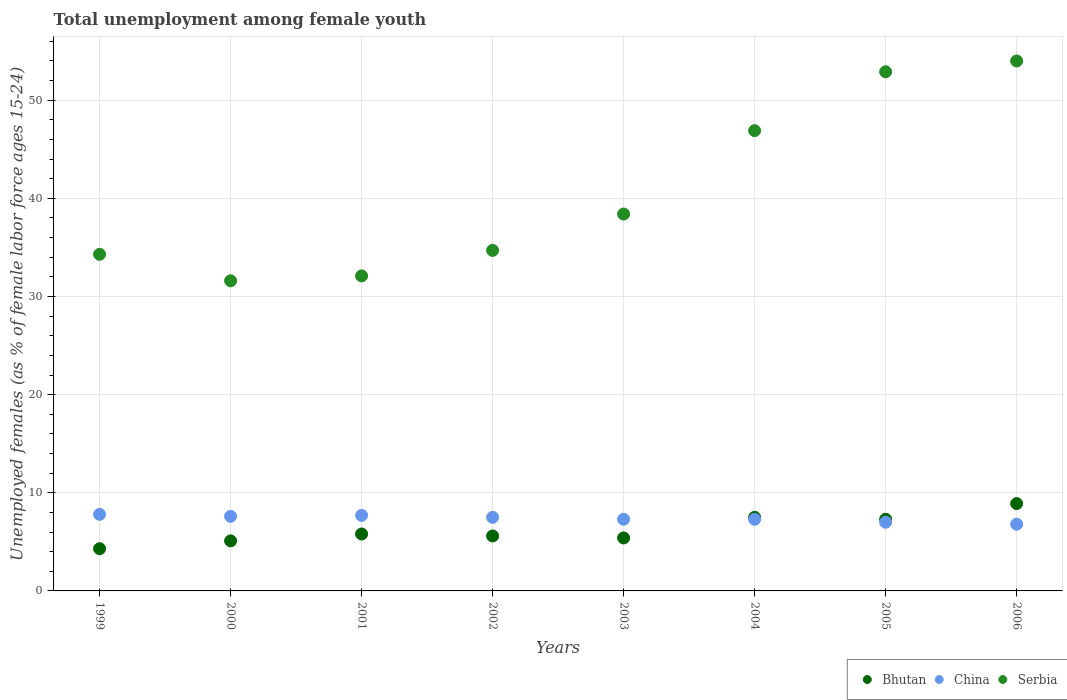What is the percentage of unemployed females in in China in 2001?
Give a very brief answer. 7.7. Across all years, what is the minimum percentage of unemployed females in in Bhutan?
Your response must be concise. 4.3. In which year was the percentage of unemployed females in in China maximum?
Provide a succinct answer. 1999. In which year was the percentage of unemployed females in in China minimum?
Offer a very short reply. 2006. What is the total percentage of unemployed females in in China in the graph?
Ensure brevity in your answer.  59. What is the difference between the percentage of unemployed females in in Serbia in 1999 and that in 2005?
Your answer should be very brief. -18.6. What is the difference between the percentage of unemployed females in in Serbia in 2000 and the percentage of unemployed females in in China in 2001?
Provide a short and direct response. 23.9. What is the average percentage of unemployed females in in Bhutan per year?
Your answer should be very brief. 6.24. In the year 2000, what is the difference between the percentage of unemployed females in in China and percentage of unemployed females in in Bhutan?
Provide a succinct answer. 2.5. In how many years, is the percentage of unemployed females in in Serbia greater than 24 %?
Offer a terse response. 8. What is the ratio of the percentage of unemployed females in in Bhutan in 2005 to that in 2006?
Your response must be concise. 0.82. Is the percentage of unemployed females in in China in 2001 less than that in 2004?
Offer a terse response. No. What is the difference between the highest and the second highest percentage of unemployed females in in Serbia?
Give a very brief answer. 1.1. In how many years, is the percentage of unemployed females in in Serbia greater than the average percentage of unemployed females in in Serbia taken over all years?
Keep it short and to the point. 3. Is the percentage of unemployed females in in Serbia strictly greater than the percentage of unemployed females in in Bhutan over the years?
Provide a short and direct response. Yes. How many dotlines are there?
Provide a short and direct response. 3. Are the values on the major ticks of Y-axis written in scientific E-notation?
Provide a succinct answer. No. Does the graph contain any zero values?
Ensure brevity in your answer.  No. Does the graph contain grids?
Provide a succinct answer. Yes. How are the legend labels stacked?
Offer a terse response. Horizontal. What is the title of the graph?
Keep it short and to the point. Total unemployment among female youth. Does "Turkey" appear as one of the legend labels in the graph?
Provide a succinct answer. No. What is the label or title of the Y-axis?
Your answer should be very brief. Unemployed females (as % of female labor force ages 15-24). What is the Unemployed females (as % of female labor force ages 15-24) of Bhutan in 1999?
Your response must be concise. 4.3. What is the Unemployed females (as % of female labor force ages 15-24) of China in 1999?
Your answer should be compact. 7.8. What is the Unemployed females (as % of female labor force ages 15-24) in Serbia in 1999?
Keep it short and to the point. 34.3. What is the Unemployed females (as % of female labor force ages 15-24) in Bhutan in 2000?
Your answer should be very brief. 5.1. What is the Unemployed females (as % of female labor force ages 15-24) of China in 2000?
Offer a very short reply. 7.6. What is the Unemployed females (as % of female labor force ages 15-24) of Serbia in 2000?
Give a very brief answer. 31.6. What is the Unemployed females (as % of female labor force ages 15-24) in Bhutan in 2001?
Ensure brevity in your answer.  5.8. What is the Unemployed females (as % of female labor force ages 15-24) in China in 2001?
Provide a succinct answer. 7.7. What is the Unemployed females (as % of female labor force ages 15-24) of Serbia in 2001?
Provide a short and direct response. 32.1. What is the Unemployed females (as % of female labor force ages 15-24) in Bhutan in 2002?
Keep it short and to the point. 5.6. What is the Unemployed females (as % of female labor force ages 15-24) of China in 2002?
Give a very brief answer. 7.5. What is the Unemployed females (as % of female labor force ages 15-24) in Serbia in 2002?
Provide a short and direct response. 34.7. What is the Unemployed females (as % of female labor force ages 15-24) of Bhutan in 2003?
Your answer should be very brief. 5.4. What is the Unemployed females (as % of female labor force ages 15-24) in China in 2003?
Keep it short and to the point. 7.3. What is the Unemployed females (as % of female labor force ages 15-24) in Serbia in 2003?
Make the answer very short. 38.4. What is the Unemployed females (as % of female labor force ages 15-24) of Bhutan in 2004?
Make the answer very short. 7.5. What is the Unemployed females (as % of female labor force ages 15-24) in China in 2004?
Your answer should be very brief. 7.3. What is the Unemployed females (as % of female labor force ages 15-24) of Serbia in 2004?
Your answer should be very brief. 46.9. What is the Unemployed females (as % of female labor force ages 15-24) in Bhutan in 2005?
Offer a terse response. 7.3. What is the Unemployed females (as % of female labor force ages 15-24) of China in 2005?
Give a very brief answer. 7. What is the Unemployed females (as % of female labor force ages 15-24) in Serbia in 2005?
Ensure brevity in your answer.  52.9. What is the Unemployed females (as % of female labor force ages 15-24) in Bhutan in 2006?
Ensure brevity in your answer.  8.9. What is the Unemployed females (as % of female labor force ages 15-24) of China in 2006?
Provide a succinct answer. 6.8. Across all years, what is the maximum Unemployed females (as % of female labor force ages 15-24) of Bhutan?
Provide a short and direct response. 8.9. Across all years, what is the maximum Unemployed females (as % of female labor force ages 15-24) of China?
Offer a terse response. 7.8. Across all years, what is the maximum Unemployed females (as % of female labor force ages 15-24) in Serbia?
Make the answer very short. 54. Across all years, what is the minimum Unemployed females (as % of female labor force ages 15-24) of Bhutan?
Provide a short and direct response. 4.3. Across all years, what is the minimum Unemployed females (as % of female labor force ages 15-24) of China?
Your answer should be compact. 6.8. Across all years, what is the minimum Unemployed females (as % of female labor force ages 15-24) in Serbia?
Your answer should be very brief. 31.6. What is the total Unemployed females (as % of female labor force ages 15-24) of Bhutan in the graph?
Provide a succinct answer. 49.9. What is the total Unemployed females (as % of female labor force ages 15-24) of Serbia in the graph?
Your answer should be very brief. 324.9. What is the difference between the Unemployed females (as % of female labor force ages 15-24) in Bhutan in 1999 and that in 2000?
Make the answer very short. -0.8. What is the difference between the Unemployed females (as % of female labor force ages 15-24) of China in 1999 and that in 2000?
Provide a succinct answer. 0.2. What is the difference between the Unemployed females (as % of female labor force ages 15-24) in Bhutan in 1999 and that in 2001?
Offer a very short reply. -1.5. What is the difference between the Unemployed females (as % of female labor force ages 15-24) in China in 1999 and that in 2001?
Provide a succinct answer. 0.1. What is the difference between the Unemployed females (as % of female labor force ages 15-24) of China in 1999 and that in 2002?
Provide a short and direct response. 0.3. What is the difference between the Unemployed females (as % of female labor force ages 15-24) of Bhutan in 1999 and that in 2003?
Give a very brief answer. -1.1. What is the difference between the Unemployed females (as % of female labor force ages 15-24) of Serbia in 1999 and that in 2004?
Your answer should be very brief. -12.6. What is the difference between the Unemployed females (as % of female labor force ages 15-24) in Serbia in 1999 and that in 2005?
Your response must be concise. -18.6. What is the difference between the Unemployed females (as % of female labor force ages 15-24) in Bhutan in 1999 and that in 2006?
Offer a very short reply. -4.6. What is the difference between the Unemployed females (as % of female labor force ages 15-24) of China in 1999 and that in 2006?
Your answer should be compact. 1. What is the difference between the Unemployed females (as % of female labor force ages 15-24) in Serbia in 1999 and that in 2006?
Provide a succinct answer. -19.7. What is the difference between the Unemployed females (as % of female labor force ages 15-24) in Serbia in 2000 and that in 2001?
Make the answer very short. -0.5. What is the difference between the Unemployed females (as % of female labor force ages 15-24) of Bhutan in 2000 and that in 2002?
Give a very brief answer. -0.5. What is the difference between the Unemployed females (as % of female labor force ages 15-24) of Serbia in 2000 and that in 2002?
Ensure brevity in your answer.  -3.1. What is the difference between the Unemployed females (as % of female labor force ages 15-24) in Bhutan in 2000 and that in 2003?
Offer a terse response. -0.3. What is the difference between the Unemployed females (as % of female labor force ages 15-24) of Serbia in 2000 and that in 2004?
Provide a succinct answer. -15.3. What is the difference between the Unemployed females (as % of female labor force ages 15-24) of China in 2000 and that in 2005?
Keep it short and to the point. 0.6. What is the difference between the Unemployed females (as % of female labor force ages 15-24) of Serbia in 2000 and that in 2005?
Ensure brevity in your answer.  -21.3. What is the difference between the Unemployed females (as % of female labor force ages 15-24) in Serbia in 2000 and that in 2006?
Give a very brief answer. -22.4. What is the difference between the Unemployed females (as % of female labor force ages 15-24) of China in 2001 and that in 2002?
Your answer should be compact. 0.2. What is the difference between the Unemployed females (as % of female labor force ages 15-24) of Bhutan in 2001 and that in 2003?
Keep it short and to the point. 0.4. What is the difference between the Unemployed females (as % of female labor force ages 15-24) in China in 2001 and that in 2003?
Your answer should be compact. 0.4. What is the difference between the Unemployed females (as % of female labor force ages 15-24) of China in 2001 and that in 2004?
Give a very brief answer. 0.4. What is the difference between the Unemployed females (as % of female labor force ages 15-24) of Serbia in 2001 and that in 2004?
Provide a succinct answer. -14.8. What is the difference between the Unemployed females (as % of female labor force ages 15-24) in Serbia in 2001 and that in 2005?
Your answer should be compact. -20.8. What is the difference between the Unemployed females (as % of female labor force ages 15-24) of Bhutan in 2001 and that in 2006?
Provide a succinct answer. -3.1. What is the difference between the Unemployed females (as % of female labor force ages 15-24) in Serbia in 2001 and that in 2006?
Your answer should be very brief. -21.9. What is the difference between the Unemployed females (as % of female labor force ages 15-24) in Bhutan in 2002 and that in 2003?
Make the answer very short. 0.2. What is the difference between the Unemployed females (as % of female labor force ages 15-24) in China in 2002 and that in 2003?
Your response must be concise. 0.2. What is the difference between the Unemployed females (as % of female labor force ages 15-24) in Serbia in 2002 and that in 2003?
Your answer should be compact. -3.7. What is the difference between the Unemployed females (as % of female labor force ages 15-24) in Bhutan in 2002 and that in 2004?
Offer a very short reply. -1.9. What is the difference between the Unemployed females (as % of female labor force ages 15-24) in China in 2002 and that in 2004?
Provide a succinct answer. 0.2. What is the difference between the Unemployed females (as % of female labor force ages 15-24) of Serbia in 2002 and that in 2005?
Offer a terse response. -18.2. What is the difference between the Unemployed females (as % of female labor force ages 15-24) in Bhutan in 2002 and that in 2006?
Give a very brief answer. -3.3. What is the difference between the Unemployed females (as % of female labor force ages 15-24) in Serbia in 2002 and that in 2006?
Ensure brevity in your answer.  -19.3. What is the difference between the Unemployed females (as % of female labor force ages 15-24) in China in 2003 and that in 2004?
Give a very brief answer. 0. What is the difference between the Unemployed females (as % of female labor force ages 15-24) in Bhutan in 2003 and that in 2006?
Offer a terse response. -3.5. What is the difference between the Unemployed females (as % of female labor force ages 15-24) of Serbia in 2003 and that in 2006?
Make the answer very short. -15.6. What is the difference between the Unemployed females (as % of female labor force ages 15-24) of Bhutan in 2004 and that in 2005?
Your answer should be compact. 0.2. What is the difference between the Unemployed females (as % of female labor force ages 15-24) of Bhutan in 2005 and that in 2006?
Make the answer very short. -1.6. What is the difference between the Unemployed females (as % of female labor force ages 15-24) of China in 2005 and that in 2006?
Offer a terse response. 0.2. What is the difference between the Unemployed females (as % of female labor force ages 15-24) of Bhutan in 1999 and the Unemployed females (as % of female labor force ages 15-24) of Serbia in 2000?
Provide a succinct answer. -27.3. What is the difference between the Unemployed females (as % of female labor force ages 15-24) of China in 1999 and the Unemployed females (as % of female labor force ages 15-24) of Serbia in 2000?
Provide a succinct answer. -23.8. What is the difference between the Unemployed females (as % of female labor force ages 15-24) in Bhutan in 1999 and the Unemployed females (as % of female labor force ages 15-24) in China in 2001?
Offer a terse response. -3.4. What is the difference between the Unemployed females (as % of female labor force ages 15-24) of Bhutan in 1999 and the Unemployed females (as % of female labor force ages 15-24) of Serbia in 2001?
Make the answer very short. -27.8. What is the difference between the Unemployed females (as % of female labor force ages 15-24) of China in 1999 and the Unemployed females (as % of female labor force ages 15-24) of Serbia in 2001?
Offer a terse response. -24.3. What is the difference between the Unemployed females (as % of female labor force ages 15-24) of Bhutan in 1999 and the Unemployed females (as % of female labor force ages 15-24) of China in 2002?
Ensure brevity in your answer.  -3.2. What is the difference between the Unemployed females (as % of female labor force ages 15-24) of Bhutan in 1999 and the Unemployed females (as % of female labor force ages 15-24) of Serbia in 2002?
Provide a succinct answer. -30.4. What is the difference between the Unemployed females (as % of female labor force ages 15-24) in China in 1999 and the Unemployed females (as % of female labor force ages 15-24) in Serbia in 2002?
Provide a succinct answer. -26.9. What is the difference between the Unemployed females (as % of female labor force ages 15-24) in Bhutan in 1999 and the Unemployed females (as % of female labor force ages 15-24) in Serbia in 2003?
Give a very brief answer. -34.1. What is the difference between the Unemployed females (as % of female labor force ages 15-24) in China in 1999 and the Unemployed females (as % of female labor force ages 15-24) in Serbia in 2003?
Offer a terse response. -30.6. What is the difference between the Unemployed females (as % of female labor force ages 15-24) of Bhutan in 1999 and the Unemployed females (as % of female labor force ages 15-24) of Serbia in 2004?
Provide a short and direct response. -42.6. What is the difference between the Unemployed females (as % of female labor force ages 15-24) of China in 1999 and the Unemployed females (as % of female labor force ages 15-24) of Serbia in 2004?
Your answer should be very brief. -39.1. What is the difference between the Unemployed females (as % of female labor force ages 15-24) in Bhutan in 1999 and the Unemployed females (as % of female labor force ages 15-24) in Serbia in 2005?
Offer a very short reply. -48.6. What is the difference between the Unemployed females (as % of female labor force ages 15-24) of China in 1999 and the Unemployed females (as % of female labor force ages 15-24) of Serbia in 2005?
Make the answer very short. -45.1. What is the difference between the Unemployed females (as % of female labor force ages 15-24) in Bhutan in 1999 and the Unemployed females (as % of female labor force ages 15-24) in Serbia in 2006?
Your answer should be compact. -49.7. What is the difference between the Unemployed females (as % of female labor force ages 15-24) of China in 1999 and the Unemployed females (as % of female labor force ages 15-24) of Serbia in 2006?
Offer a terse response. -46.2. What is the difference between the Unemployed females (as % of female labor force ages 15-24) of Bhutan in 2000 and the Unemployed females (as % of female labor force ages 15-24) of China in 2001?
Provide a short and direct response. -2.6. What is the difference between the Unemployed females (as % of female labor force ages 15-24) in Bhutan in 2000 and the Unemployed females (as % of female labor force ages 15-24) in Serbia in 2001?
Offer a terse response. -27. What is the difference between the Unemployed females (as % of female labor force ages 15-24) of China in 2000 and the Unemployed females (as % of female labor force ages 15-24) of Serbia in 2001?
Provide a succinct answer. -24.5. What is the difference between the Unemployed females (as % of female labor force ages 15-24) of Bhutan in 2000 and the Unemployed females (as % of female labor force ages 15-24) of Serbia in 2002?
Your response must be concise. -29.6. What is the difference between the Unemployed females (as % of female labor force ages 15-24) of China in 2000 and the Unemployed females (as % of female labor force ages 15-24) of Serbia in 2002?
Make the answer very short. -27.1. What is the difference between the Unemployed females (as % of female labor force ages 15-24) of Bhutan in 2000 and the Unemployed females (as % of female labor force ages 15-24) of Serbia in 2003?
Your answer should be compact. -33.3. What is the difference between the Unemployed females (as % of female labor force ages 15-24) of China in 2000 and the Unemployed females (as % of female labor force ages 15-24) of Serbia in 2003?
Offer a very short reply. -30.8. What is the difference between the Unemployed females (as % of female labor force ages 15-24) of Bhutan in 2000 and the Unemployed females (as % of female labor force ages 15-24) of China in 2004?
Your response must be concise. -2.2. What is the difference between the Unemployed females (as % of female labor force ages 15-24) in Bhutan in 2000 and the Unemployed females (as % of female labor force ages 15-24) in Serbia in 2004?
Make the answer very short. -41.8. What is the difference between the Unemployed females (as % of female labor force ages 15-24) of China in 2000 and the Unemployed females (as % of female labor force ages 15-24) of Serbia in 2004?
Offer a very short reply. -39.3. What is the difference between the Unemployed females (as % of female labor force ages 15-24) of Bhutan in 2000 and the Unemployed females (as % of female labor force ages 15-24) of China in 2005?
Offer a very short reply. -1.9. What is the difference between the Unemployed females (as % of female labor force ages 15-24) of Bhutan in 2000 and the Unemployed females (as % of female labor force ages 15-24) of Serbia in 2005?
Give a very brief answer. -47.8. What is the difference between the Unemployed females (as % of female labor force ages 15-24) of China in 2000 and the Unemployed females (as % of female labor force ages 15-24) of Serbia in 2005?
Give a very brief answer. -45.3. What is the difference between the Unemployed females (as % of female labor force ages 15-24) in Bhutan in 2000 and the Unemployed females (as % of female labor force ages 15-24) in China in 2006?
Make the answer very short. -1.7. What is the difference between the Unemployed females (as % of female labor force ages 15-24) of Bhutan in 2000 and the Unemployed females (as % of female labor force ages 15-24) of Serbia in 2006?
Your response must be concise. -48.9. What is the difference between the Unemployed females (as % of female labor force ages 15-24) of China in 2000 and the Unemployed females (as % of female labor force ages 15-24) of Serbia in 2006?
Provide a succinct answer. -46.4. What is the difference between the Unemployed females (as % of female labor force ages 15-24) in Bhutan in 2001 and the Unemployed females (as % of female labor force ages 15-24) in Serbia in 2002?
Make the answer very short. -28.9. What is the difference between the Unemployed females (as % of female labor force ages 15-24) of China in 2001 and the Unemployed females (as % of female labor force ages 15-24) of Serbia in 2002?
Your answer should be compact. -27. What is the difference between the Unemployed females (as % of female labor force ages 15-24) in Bhutan in 2001 and the Unemployed females (as % of female labor force ages 15-24) in Serbia in 2003?
Offer a terse response. -32.6. What is the difference between the Unemployed females (as % of female labor force ages 15-24) of China in 2001 and the Unemployed females (as % of female labor force ages 15-24) of Serbia in 2003?
Offer a terse response. -30.7. What is the difference between the Unemployed females (as % of female labor force ages 15-24) in Bhutan in 2001 and the Unemployed females (as % of female labor force ages 15-24) in Serbia in 2004?
Give a very brief answer. -41.1. What is the difference between the Unemployed females (as % of female labor force ages 15-24) in China in 2001 and the Unemployed females (as % of female labor force ages 15-24) in Serbia in 2004?
Make the answer very short. -39.2. What is the difference between the Unemployed females (as % of female labor force ages 15-24) of Bhutan in 2001 and the Unemployed females (as % of female labor force ages 15-24) of Serbia in 2005?
Give a very brief answer. -47.1. What is the difference between the Unemployed females (as % of female labor force ages 15-24) in China in 2001 and the Unemployed females (as % of female labor force ages 15-24) in Serbia in 2005?
Ensure brevity in your answer.  -45.2. What is the difference between the Unemployed females (as % of female labor force ages 15-24) in Bhutan in 2001 and the Unemployed females (as % of female labor force ages 15-24) in Serbia in 2006?
Give a very brief answer. -48.2. What is the difference between the Unemployed females (as % of female labor force ages 15-24) of China in 2001 and the Unemployed females (as % of female labor force ages 15-24) of Serbia in 2006?
Ensure brevity in your answer.  -46.3. What is the difference between the Unemployed females (as % of female labor force ages 15-24) of Bhutan in 2002 and the Unemployed females (as % of female labor force ages 15-24) of China in 2003?
Ensure brevity in your answer.  -1.7. What is the difference between the Unemployed females (as % of female labor force ages 15-24) of Bhutan in 2002 and the Unemployed females (as % of female labor force ages 15-24) of Serbia in 2003?
Offer a very short reply. -32.8. What is the difference between the Unemployed females (as % of female labor force ages 15-24) of China in 2002 and the Unemployed females (as % of female labor force ages 15-24) of Serbia in 2003?
Make the answer very short. -30.9. What is the difference between the Unemployed females (as % of female labor force ages 15-24) of Bhutan in 2002 and the Unemployed females (as % of female labor force ages 15-24) of Serbia in 2004?
Provide a succinct answer. -41.3. What is the difference between the Unemployed females (as % of female labor force ages 15-24) of China in 2002 and the Unemployed females (as % of female labor force ages 15-24) of Serbia in 2004?
Offer a terse response. -39.4. What is the difference between the Unemployed females (as % of female labor force ages 15-24) of Bhutan in 2002 and the Unemployed females (as % of female labor force ages 15-24) of Serbia in 2005?
Provide a succinct answer. -47.3. What is the difference between the Unemployed females (as % of female labor force ages 15-24) in China in 2002 and the Unemployed females (as % of female labor force ages 15-24) in Serbia in 2005?
Your response must be concise. -45.4. What is the difference between the Unemployed females (as % of female labor force ages 15-24) in Bhutan in 2002 and the Unemployed females (as % of female labor force ages 15-24) in Serbia in 2006?
Offer a very short reply. -48.4. What is the difference between the Unemployed females (as % of female labor force ages 15-24) of China in 2002 and the Unemployed females (as % of female labor force ages 15-24) of Serbia in 2006?
Give a very brief answer. -46.5. What is the difference between the Unemployed females (as % of female labor force ages 15-24) of Bhutan in 2003 and the Unemployed females (as % of female labor force ages 15-24) of China in 2004?
Provide a succinct answer. -1.9. What is the difference between the Unemployed females (as % of female labor force ages 15-24) in Bhutan in 2003 and the Unemployed females (as % of female labor force ages 15-24) in Serbia in 2004?
Ensure brevity in your answer.  -41.5. What is the difference between the Unemployed females (as % of female labor force ages 15-24) in China in 2003 and the Unemployed females (as % of female labor force ages 15-24) in Serbia in 2004?
Offer a very short reply. -39.6. What is the difference between the Unemployed females (as % of female labor force ages 15-24) of Bhutan in 2003 and the Unemployed females (as % of female labor force ages 15-24) of Serbia in 2005?
Keep it short and to the point. -47.5. What is the difference between the Unemployed females (as % of female labor force ages 15-24) in China in 2003 and the Unemployed females (as % of female labor force ages 15-24) in Serbia in 2005?
Offer a very short reply. -45.6. What is the difference between the Unemployed females (as % of female labor force ages 15-24) in Bhutan in 2003 and the Unemployed females (as % of female labor force ages 15-24) in Serbia in 2006?
Ensure brevity in your answer.  -48.6. What is the difference between the Unemployed females (as % of female labor force ages 15-24) in China in 2003 and the Unemployed females (as % of female labor force ages 15-24) in Serbia in 2006?
Provide a short and direct response. -46.7. What is the difference between the Unemployed females (as % of female labor force ages 15-24) of Bhutan in 2004 and the Unemployed females (as % of female labor force ages 15-24) of Serbia in 2005?
Offer a terse response. -45.4. What is the difference between the Unemployed females (as % of female labor force ages 15-24) of China in 2004 and the Unemployed females (as % of female labor force ages 15-24) of Serbia in 2005?
Your answer should be compact. -45.6. What is the difference between the Unemployed females (as % of female labor force ages 15-24) in Bhutan in 2004 and the Unemployed females (as % of female labor force ages 15-24) in China in 2006?
Offer a very short reply. 0.7. What is the difference between the Unemployed females (as % of female labor force ages 15-24) in Bhutan in 2004 and the Unemployed females (as % of female labor force ages 15-24) in Serbia in 2006?
Give a very brief answer. -46.5. What is the difference between the Unemployed females (as % of female labor force ages 15-24) of China in 2004 and the Unemployed females (as % of female labor force ages 15-24) of Serbia in 2006?
Give a very brief answer. -46.7. What is the difference between the Unemployed females (as % of female labor force ages 15-24) of Bhutan in 2005 and the Unemployed females (as % of female labor force ages 15-24) of Serbia in 2006?
Offer a terse response. -46.7. What is the difference between the Unemployed females (as % of female labor force ages 15-24) of China in 2005 and the Unemployed females (as % of female labor force ages 15-24) of Serbia in 2006?
Your response must be concise. -47. What is the average Unemployed females (as % of female labor force ages 15-24) of Bhutan per year?
Your response must be concise. 6.24. What is the average Unemployed females (as % of female labor force ages 15-24) of China per year?
Ensure brevity in your answer.  7.38. What is the average Unemployed females (as % of female labor force ages 15-24) of Serbia per year?
Give a very brief answer. 40.61. In the year 1999, what is the difference between the Unemployed females (as % of female labor force ages 15-24) of Bhutan and Unemployed females (as % of female labor force ages 15-24) of China?
Give a very brief answer. -3.5. In the year 1999, what is the difference between the Unemployed females (as % of female labor force ages 15-24) in China and Unemployed females (as % of female labor force ages 15-24) in Serbia?
Provide a succinct answer. -26.5. In the year 2000, what is the difference between the Unemployed females (as % of female labor force ages 15-24) of Bhutan and Unemployed females (as % of female labor force ages 15-24) of China?
Offer a very short reply. -2.5. In the year 2000, what is the difference between the Unemployed females (as % of female labor force ages 15-24) in Bhutan and Unemployed females (as % of female labor force ages 15-24) in Serbia?
Your answer should be compact. -26.5. In the year 2000, what is the difference between the Unemployed females (as % of female labor force ages 15-24) of China and Unemployed females (as % of female labor force ages 15-24) of Serbia?
Ensure brevity in your answer.  -24. In the year 2001, what is the difference between the Unemployed females (as % of female labor force ages 15-24) in Bhutan and Unemployed females (as % of female labor force ages 15-24) in Serbia?
Your answer should be compact. -26.3. In the year 2001, what is the difference between the Unemployed females (as % of female labor force ages 15-24) in China and Unemployed females (as % of female labor force ages 15-24) in Serbia?
Your response must be concise. -24.4. In the year 2002, what is the difference between the Unemployed females (as % of female labor force ages 15-24) of Bhutan and Unemployed females (as % of female labor force ages 15-24) of Serbia?
Provide a short and direct response. -29.1. In the year 2002, what is the difference between the Unemployed females (as % of female labor force ages 15-24) of China and Unemployed females (as % of female labor force ages 15-24) of Serbia?
Offer a terse response. -27.2. In the year 2003, what is the difference between the Unemployed females (as % of female labor force ages 15-24) of Bhutan and Unemployed females (as % of female labor force ages 15-24) of Serbia?
Your answer should be very brief. -33. In the year 2003, what is the difference between the Unemployed females (as % of female labor force ages 15-24) of China and Unemployed females (as % of female labor force ages 15-24) of Serbia?
Offer a very short reply. -31.1. In the year 2004, what is the difference between the Unemployed females (as % of female labor force ages 15-24) of Bhutan and Unemployed females (as % of female labor force ages 15-24) of China?
Offer a terse response. 0.2. In the year 2004, what is the difference between the Unemployed females (as % of female labor force ages 15-24) in Bhutan and Unemployed females (as % of female labor force ages 15-24) in Serbia?
Provide a short and direct response. -39.4. In the year 2004, what is the difference between the Unemployed females (as % of female labor force ages 15-24) in China and Unemployed females (as % of female labor force ages 15-24) in Serbia?
Offer a terse response. -39.6. In the year 2005, what is the difference between the Unemployed females (as % of female labor force ages 15-24) in Bhutan and Unemployed females (as % of female labor force ages 15-24) in China?
Provide a short and direct response. 0.3. In the year 2005, what is the difference between the Unemployed females (as % of female labor force ages 15-24) of Bhutan and Unemployed females (as % of female labor force ages 15-24) of Serbia?
Your answer should be compact. -45.6. In the year 2005, what is the difference between the Unemployed females (as % of female labor force ages 15-24) of China and Unemployed females (as % of female labor force ages 15-24) of Serbia?
Keep it short and to the point. -45.9. In the year 2006, what is the difference between the Unemployed females (as % of female labor force ages 15-24) in Bhutan and Unemployed females (as % of female labor force ages 15-24) in Serbia?
Give a very brief answer. -45.1. In the year 2006, what is the difference between the Unemployed females (as % of female labor force ages 15-24) of China and Unemployed females (as % of female labor force ages 15-24) of Serbia?
Offer a very short reply. -47.2. What is the ratio of the Unemployed females (as % of female labor force ages 15-24) in Bhutan in 1999 to that in 2000?
Your answer should be very brief. 0.84. What is the ratio of the Unemployed females (as % of female labor force ages 15-24) in China in 1999 to that in 2000?
Your answer should be compact. 1.03. What is the ratio of the Unemployed females (as % of female labor force ages 15-24) of Serbia in 1999 to that in 2000?
Your answer should be compact. 1.09. What is the ratio of the Unemployed females (as % of female labor force ages 15-24) in Bhutan in 1999 to that in 2001?
Provide a short and direct response. 0.74. What is the ratio of the Unemployed females (as % of female labor force ages 15-24) in Serbia in 1999 to that in 2001?
Ensure brevity in your answer.  1.07. What is the ratio of the Unemployed females (as % of female labor force ages 15-24) of Bhutan in 1999 to that in 2002?
Keep it short and to the point. 0.77. What is the ratio of the Unemployed females (as % of female labor force ages 15-24) in Serbia in 1999 to that in 2002?
Give a very brief answer. 0.99. What is the ratio of the Unemployed females (as % of female labor force ages 15-24) of Bhutan in 1999 to that in 2003?
Make the answer very short. 0.8. What is the ratio of the Unemployed females (as % of female labor force ages 15-24) of China in 1999 to that in 2003?
Make the answer very short. 1.07. What is the ratio of the Unemployed females (as % of female labor force ages 15-24) in Serbia in 1999 to that in 2003?
Provide a succinct answer. 0.89. What is the ratio of the Unemployed females (as % of female labor force ages 15-24) in Bhutan in 1999 to that in 2004?
Your answer should be compact. 0.57. What is the ratio of the Unemployed females (as % of female labor force ages 15-24) of China in 1999 to that in 2004?
Offer a terse response. 1.07. What is the ratio of the Unemployed females (as % of female labor force ages 15-24) of Serbia in 1999 to that in 2004?
Ensure brevity in your answer.  0.73. What is the ratio of the Unemployed females (as % of female labor force ages 15-24) of Bhutan in 1999 to that in 2005?
Offer a very short reply. 0.59. What is the ratio of the Unemployed females (as % of female labor force ages 15-24) of China in 1999 to that in 2005?
Ensure brevity in your answer.  1.11. What is the ratio of the Unemployed females (as % of female labor force ages 15-24) in Serbia in 1999 to that in 2005?
Offer a terse response. 0.65. What is the ratio of the Unemployed females (as % of female labor force ages 15-24) in Bhutan in 1999 to that in 2006?
Make the answer very short. 0.48. What is the ratio of the Unemployed females (as % of female labor force ages 15-24) of China in 1999 to that in 2006?
Make the answer very short. 1.15. What is the ratio of the Unemployed females (as % of female labor force ages 15-24) in Serbia in 1999 to that in 2006?
Offer a very short reply. 0.64. What is the ratio of the Unemployed females (as % of female labor force ages 15-24) in Bhutan in 2000 to that in 2001?
Ensure brevity in your answer.  0.88. What is the ratio of the Unemployed females (as % of female labor force ages 15-24) of China in 2000 to that in 2001?
Keep it short and to the point. 0.99. What is the ratio of the Unemployed females (as % of female labor force ages 15-24) in Serbia in 2000 to that in 2001?
Your answer should be compact. 0.98. What is the ratio of the Unemployed females (as % of female labor force ages 15-24) of Bhutan in 2000 to that in 2002?
Ensure brevity in your answer.  0.91. What is the ratio of the Unemployed females (as % of female labor force ages 15-24) of China in 2000 to that in 2002?
Provide a succinct answer. 1.01. What is the ratio of the Unemployed females (as % of female labor force ages 15-24) in Serbia in 2000 to that in 2002?
Give a very brief answer. 0.91. What is the ratio of the Unemployed females (as % of female labor force ages 15-24) in China in 2000 to that in 2003?
Your answer should be compact. 1.04. What is the ratio of the Unemployed females (as % of female labor force ages 15-24) of Serbia in 2000 to that in 2003?
Provide a short and direct response. 0.82. What is the ratio of the Unemployed females (as % of female labor force ages 15-24) of Bhutan in 2000 to that in 2004?
Make the answer very short. 0.68. What is the ratio of the Unemployed females (as % of female labor force ages 15-24) of China in 2000 to that in 2004?
Your response must be concise. 1.04. What is the ratio of the Unemployed females (as % of female labor force ages 15-24) of Serbia in 2000 to that in 2004?
Ensure brevity in your answer.  0.67. What is the ratio of the Unemployed females (as % of female labor force ages 15-24) in Bhutan in 2000 to that in 2005?
Make the answer very short. 0.7. What is the ratio of the Unemployed females (as % of female labor force ages 15-24) of China in 2000 to that in 2005?
Offer a very short reply. 1.09. What is the ratio of the Unemployed females (as % of female labor force ages 15-24) of Serbia in 2000 to that in 2005?
Provide a succinct answer. 0.6. What is the ratio of the Unemployed females (as % of female labor force ages 15-24) in Bhutan in 2000 to that in 2006?
Provide a succinct answer. 0.57. What is the ratio of the Unemployed females (as % of female labor force ages 15-24) in China in 2000 to that in 2006?
Ensure brevity in your answer.  1.12. What is the ratio of the Unemployed females (as % of female labor force ages 15-24) in Serbia in 2000 to that in 2006?
Your answer should be compact. 0.59. What is the ratio of the Unemployed females (as % of female labor force ages 15-24) in Bhutan in 2001 to that in 2002?
Your response must be concise. 1.04. What is the ratio of the Unemployed females (as % of female labor force ages 15-24) of China in 2001 to that in 2002?
Offer a very short reply. 1.03. What is the ratio of the Unemployed females (as % of female labor force ages 15-24) of Serbia in 2001 to that in 2002?
Provide a short and direct response. 0.93. What is the ratio of the Unemployed females (as % of female labor force ages 15-24) in Bhutan in 2001 to that in 2003?
Keep it short and to the point. 1.07. What is the ratio of the Unemployed females (as % of female labor force ages 15-24) in China in 2001 to that in 2003?
Ensure brevity in your answer.  1.05. What is the ratio of the Unemployed females (as % of female labor force ages 15-24) in Serbia in 2001 to that in 2003?
Give a very brief answer. 0.84. What is the ratio of the Unemployed females (as % of female labor force ages 15-24) of Bhutan in 2001 to that in 2004?
Provide a succinct answer. 0.77. What is the ratio of the Unemployed females (as % of female labor force ages 15-24) in China in 2001 to that in 2004?
Offer a very short reply. 1.05. What is the ratio of the Unemployed females (as % of female labor force ages 15-24) in Serbia in 2001 to that in 2004?
Offer a very short reply. 0.68. What is the ratio of the Unemployed females (as % of female labor force ages 15-24) of Bhutan in 2001 to that in 2005?
Provide a short and direct response. 0.79. What is the ratio of the Unemployed females (as % of female labor force ages 15-24) in China in 2001 to that in 2005?
Make the answer very short. 1.1. What is the ratio of the Unemployed females (as % of female labor force ages 15-24) of Serbia in 2001 to that in 2005?
Make the answer very short. 0.61. What is the ratio of the Unemployed females (as % of female labor force ages 15-24) of Bhutan in 2001 to that in 2006?
Offer a very short reply. 0.65. What is the ratio of the Unemployed females (as % of female labor force ages 15-24) in China in 2001 to that in 2006?
Provide a short and direct response. 1.13. What is the ratio of the Unemployed females (as % of female labor force ages 15-24) in Serbia in 2001 to that in 2006?
Keep it short and to the point. 0.59. What is the ratio of the Unemployed females (as % of female labor force ages 15-24) of Bhutan in 2002 to that in 2003?
Ensure brevity in your answer.  1.04. What is the ratio of the Unemployed females (as % of female labor force ages 15-24) of China in 2002 to that in 2003?
Provide a succinct answer. 1.03. What is the ratio of the Unemployed females (as % of female labor force ages 15-24) in Serbia in 2002 to that in 2003?
Your answer should be very brief. 0.9. What is the ratio of the Unemployed females (as % of female labor force ages 15-24) in Bhutan in 2002 to that in 2004?
Ensure brevity in your answer.  0.75. What is the ratio of the Unemployed females (as % of female labor force ages 15-24) in China in 2002 to that in 2004?
Your answer should be compact. 1.03. What is the ratio of the Unemployed females (as % of female labor force ages 15-24) of Serbia in 2002 to that in 2004?
Your answer should be very brief. 0.74. What is the ratio of the Unemployed females (as % of female labor force ages 15-24) of Bhutan in 2002 to that in 2005?
Give a very brief answer. 0.77. What is the ratio of the Unemployed females (as % of female labor force ages 15-24) in China in 2002 to that in 2005?
Ensure brevity in your answer.  1.07. What is the ratio of the Unemployed females (as % of female labor force ages 15-24) in Serbia in 2002 to that in 2005?
Provide a short and direct response. 0.66. What is the ratio of the Unemployed females (as % of female labor force ages 15-24) in Bhutan in 2002 to that in 2006?
Your answer should be very brief. 0.63. What is the ratio of the Unemployed females (as % of female labor force ages 15-24) of China in 2002 to that in 2006?
Your answer should be compact. 1.1. What is the ratio of the Unemployed females (as % of female labor force ages 15-24) in Serbia in 2002 to that in 2006?
Your response must be concise. 0.64. What is the ratio of the Unemployed females (as % of female labor force ages 15-24) of Bhutan in 2003 to that in 2004?
Ensure brevity in your answer.  0.72. What is the ratio of the Unemployed females (as % of female labor force ages 15-24) in China in 2003 to that in 2004?
Your answer should be compact. 1. What is the ratio of the Unemployed females (as % of female labor force ages 15-24) in Serbia in 2003 to that in 2004?
Your response must be concise. 0.82. What is the ratio of the Unemployed females (as % of female labor force ages 15-24) in Bhutan in 2003 to that in 2005?
Make the answer very short. 0.74. What is the ratio of the Unemployed females (as % of female labor force ages 15-24) of China in 2003 to that in 2005?
Give a very brief answer. 1.04. What is the ratio of the Unemployed females (as % of female labor force ages 15-24) of Serbia in 2003 to that in 2005?
Ensure brevity in your answer.  0.73. What is the ratio of the Unemployed females (as % of female labor force ages 15-24) in Bhutan in 2003 to that in 2006?
Make the answer very short. 0.61. What is the ratio of the Unemployed females (as % of female labor force ages 15-24) in China in 2003 to that in 2006?
Ensure brevity in your answer.  1.07. What is the ratio of the Unemployed females (as % of female labor force ages 15-24) in Serbia in 2003 to that in 2006?
Your response must be concise. 0.71. What is the ratio of the Unemployed females (as % of female labor force ages 15-24) in Bhutan in 2004 to that in 2005?
Offer a terse response. 1.03. What is the ratio of the Unemployed females (as % of female labor force ages 15-24) of China in 2004 to that in 2005?
Your answer should be very brief. 1.04. What is the ratio of the Unemployed females (as % of female labor force ages 15-24) of Serbia in 2004 to that in 2005?
Offer a terse response. 0.89. What is the ratio of the Unemployed females (as % of female labor force ages 15-24) of Bhutan in 2004 to that in 2006?
Provide a short and direct response. 0.84. What is the ratio of the Unemployed females (as % of female labor force ages 15-24) in China in 2004 to that in 2006?
Offer a very short reply. 1.07. What is the ratio of the Unemployed females (as % of female labor force ages 15-24) of Serbia in 2004 to that in 2006?
Your response must be concise. 0.87. What is the ratio of the Unemployed females (as % of female labor force ages 15-24) in Bhutan in 2005 to that in 2006?
Your answer should be very brief. 0.82. What is the ratio of the Unemployed females (as % of female labor force ages 15-24) in China in 2005 to that in 2006?
Ensure brevity in your answer.  1.03. What is the ratio of the Unemployed females (as % of female labor force ages 15-24) of Serbia in 2005 to that in 2006?
Give a very brief answer. 0.98. What is the difference between the highest and the second highest Unemployed females (as % of female labor force ages 15-24) in China?
Provide a short and direct response. 0.1. What is the difference between the highest and the lowest Unemployed females (as % of female labor force ages 15-24) in Serbia?
Ensure brevity in your answer.  22.4. 